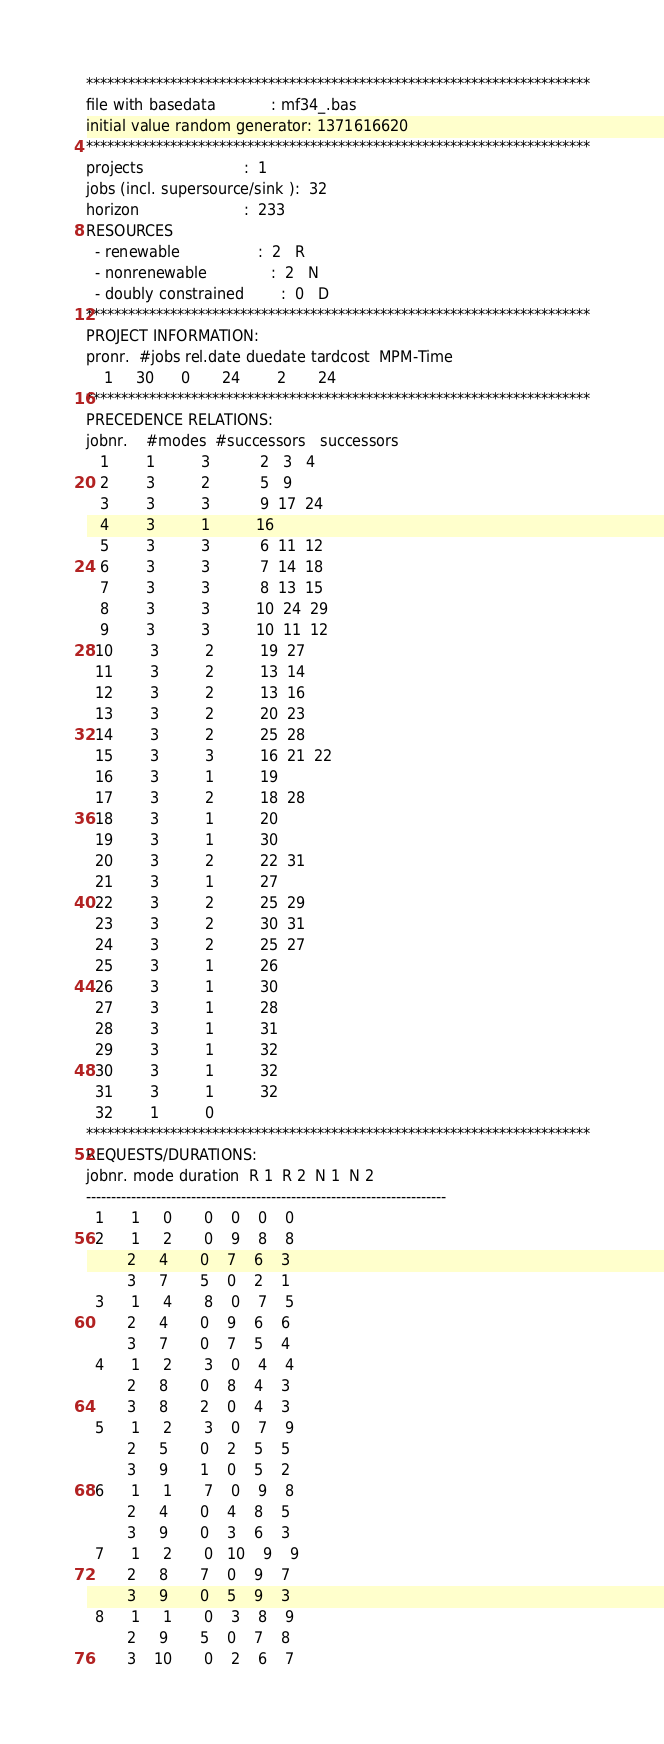<code> <loc_0><loc_0><loc_500><loc_500><_ObjectiveC_>************************************************************************
file with basedata            : mf34_.bas
initial value random generator: 1371616620
************************************************************************
projects                      :  1
jobs (incl. supersource/sink ):  32
horizon                       :  233
RESOURCES
  - renewable                 :  2   R
  - nonrenewable              :  2   N
  - doubly constrained        :  0   D
************************************************************************
PROJECT INFORMATION:
pronr.  #jobs rel.date duedate tardcost  MPM-Time
    1     30      0       24        2       24
************************************************************************
PRECEDENCE RELATIONS:
jobnr.    #modes  #successors   successors
   1        1          3           2   3   4
   2        3          2           5   9
   3        3          3           9  17  24
   4        3          1          16
   5        3          3           6  11  12
   6        3          3           7  14  18
   7        3          3           8  13  15
   8        3          3          10  24  29
   9        3          3          10  11  12
  10        3          2          19  27
  11        3          2          13  14
  12        3          2          13  16
  13        3          2          20  23
  14        3          2          25  28
  15        3          3          16  21  22
  16        3          1          19
  17        3          2          18  28
  18        3          1          20
  19        3          1          30
  20        3          2          22  31
  21        3          1          27
  22        3          2          25  29
  23        3          2          30  31
  24        3          2          25  27
  25        3          1          26
  26        3          1          30
  27        3          1          28
  28        3          1          31
  29        3          1          32
  30        3          1          32
  31        3          1          32
  32        1          0        
************************************************************************
REQUESTS/DURATIONS:
jobnr. mode duration  R 1  R 2  N 1  N 2
------------------------------------------------------------------------
  1      1     0       0    0    0    0
  2      1     2       0    9    8    8
         2     4       0    7    6    3
         3     7       5    0    2    1
  3      1     4       8    0    7    5
         2     4       0    9    6    6
         3     7       0    7    5    4
  4      1     2       3    0    4    4
         2     8       0    8    4    3
         3     8       2    0    4    3
  5      1     2       3    0    7    9
         2     5       0    2    5    5
         3     9       1    0    5    2
  6      1     1       7    0    9    8
         2     4       0    4    8    5
         3     9       0    3    6    3
  7      1     2       0   10    9    9
         2     8       7    0    9    7
         3     9       0    5    9    3
  8      1     1       0    3    8    9
         2     9       5    0    7    8
         3    10       0    2    6    7</code> 